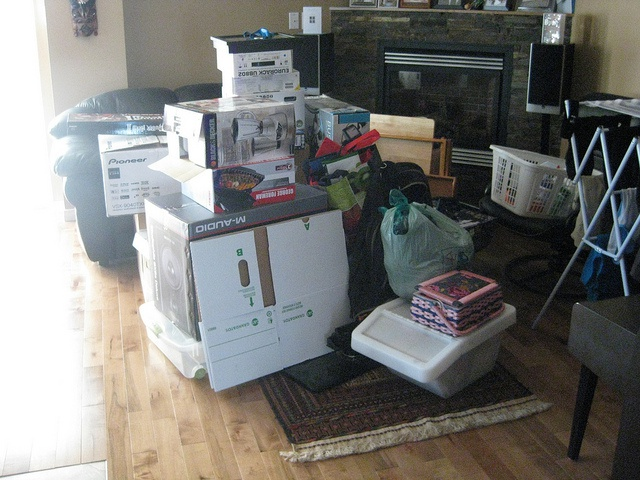Describe the objects in this image and their specific colors. I can see couch in white, darkgray, gray, and lightgray tones, tv in white, black, gray, darkgray, and purple tones, chair in white, black, and purple tones, and chair in white, black, gray, and darkgray tones in this image. 